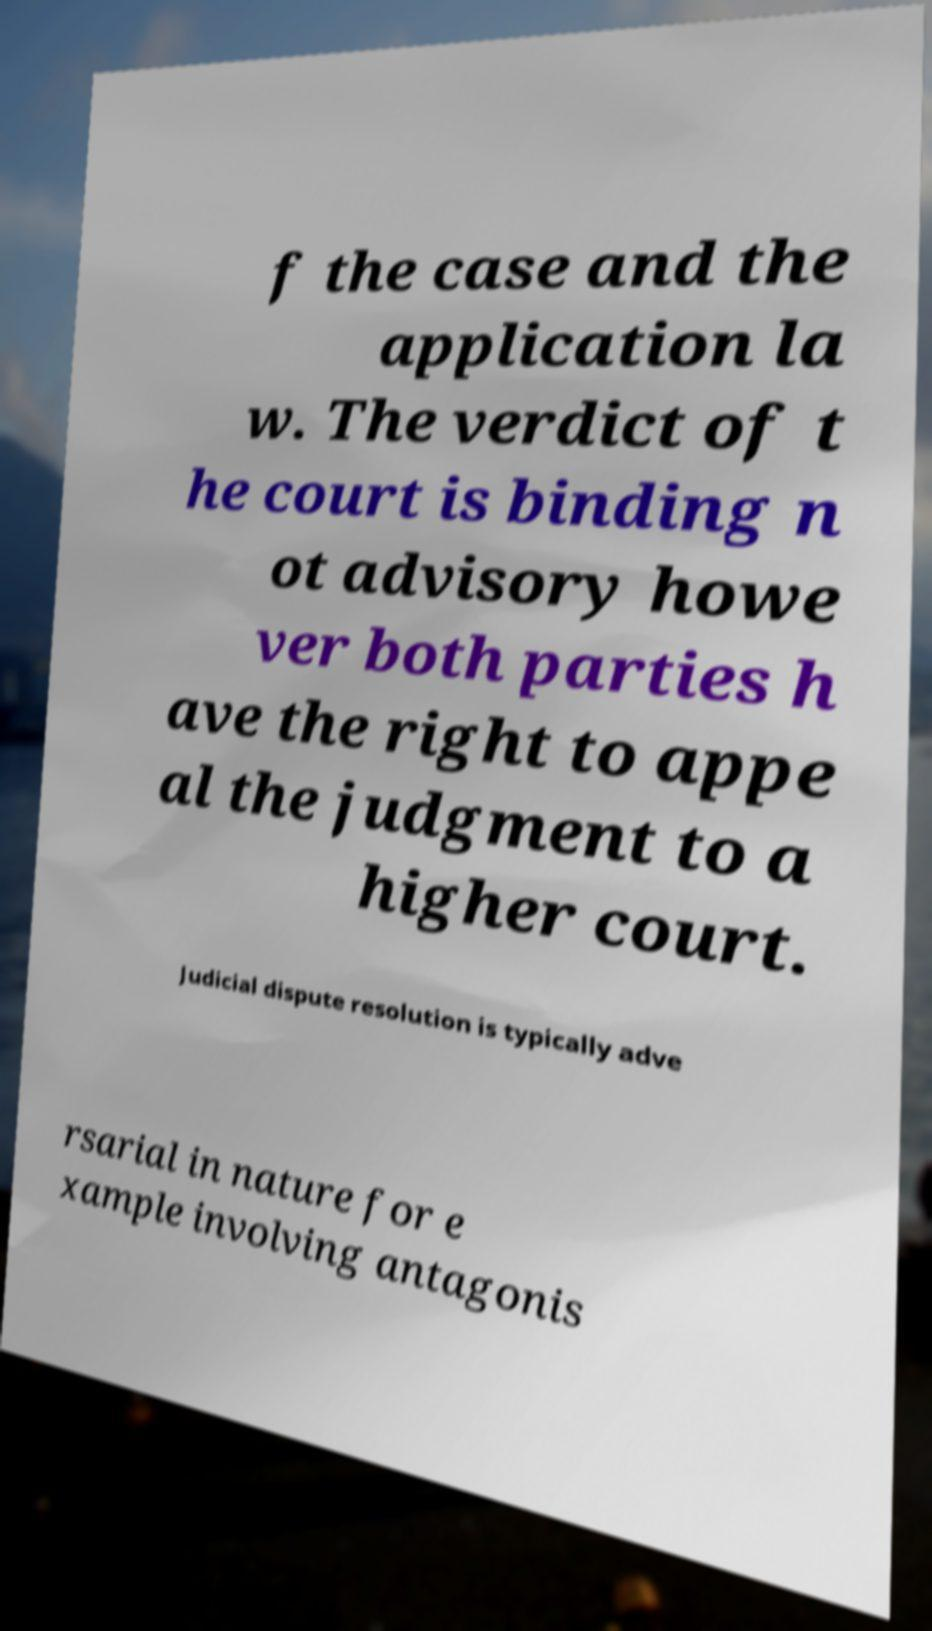Please identify and transcribe the text found in this image. f the case and the application la w. The verdict of t he court is binding n ot advisory howe ver both parties h ave the right to appe al the judgment to a higher court. Judicial dispute resolution is typically adve rsarial in nature for e xample involving antagonis 